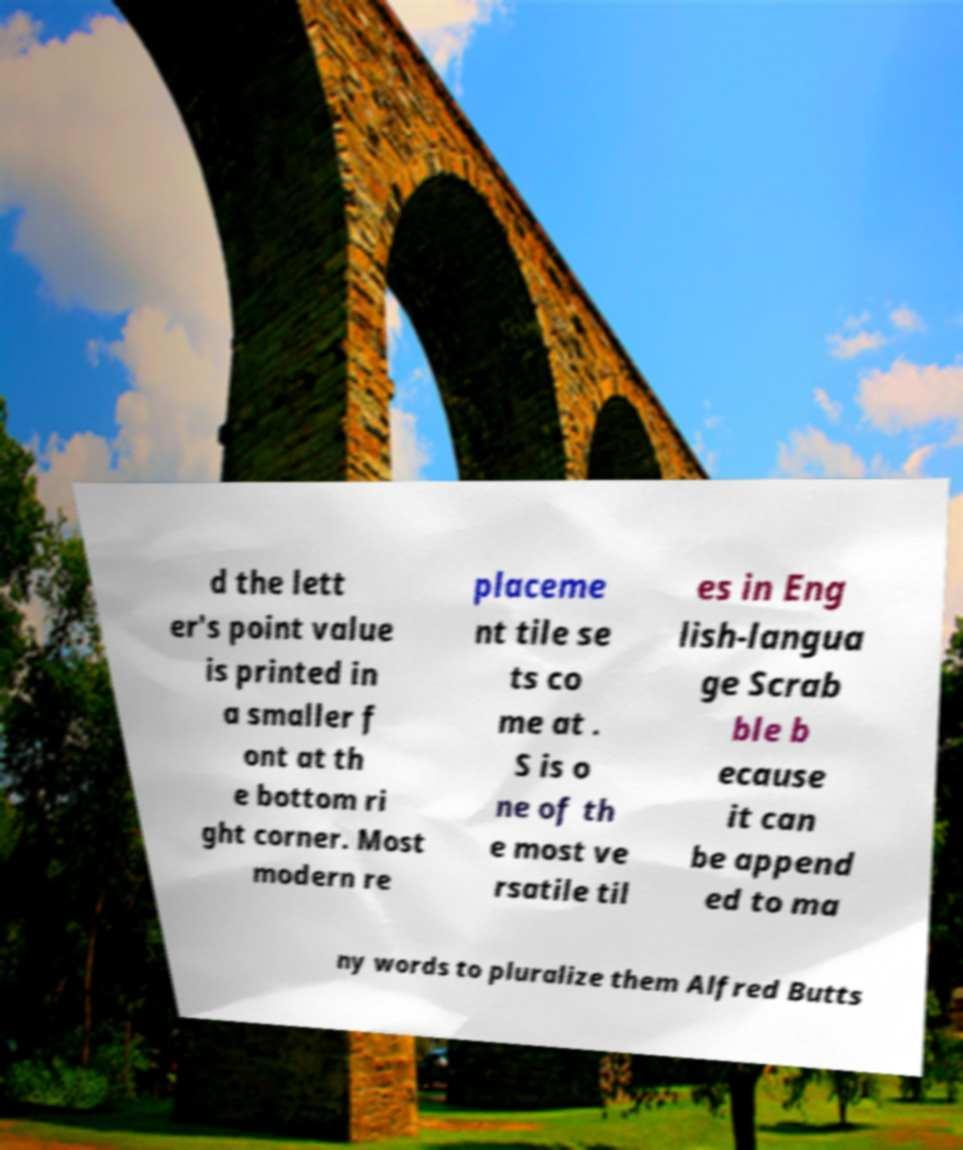Could you extract and type out the text from this image? d the lett er's point value is printed in a smaller f ont at th e bottom ri ght corner. Most modern re placeme nt tile se ts co me at . S is o ne of th e most ve rsatile til es in Eng lish-langua ge Scrab ble b ecause it can be append ed to ma ny words to pluralize them Alfred Butts 